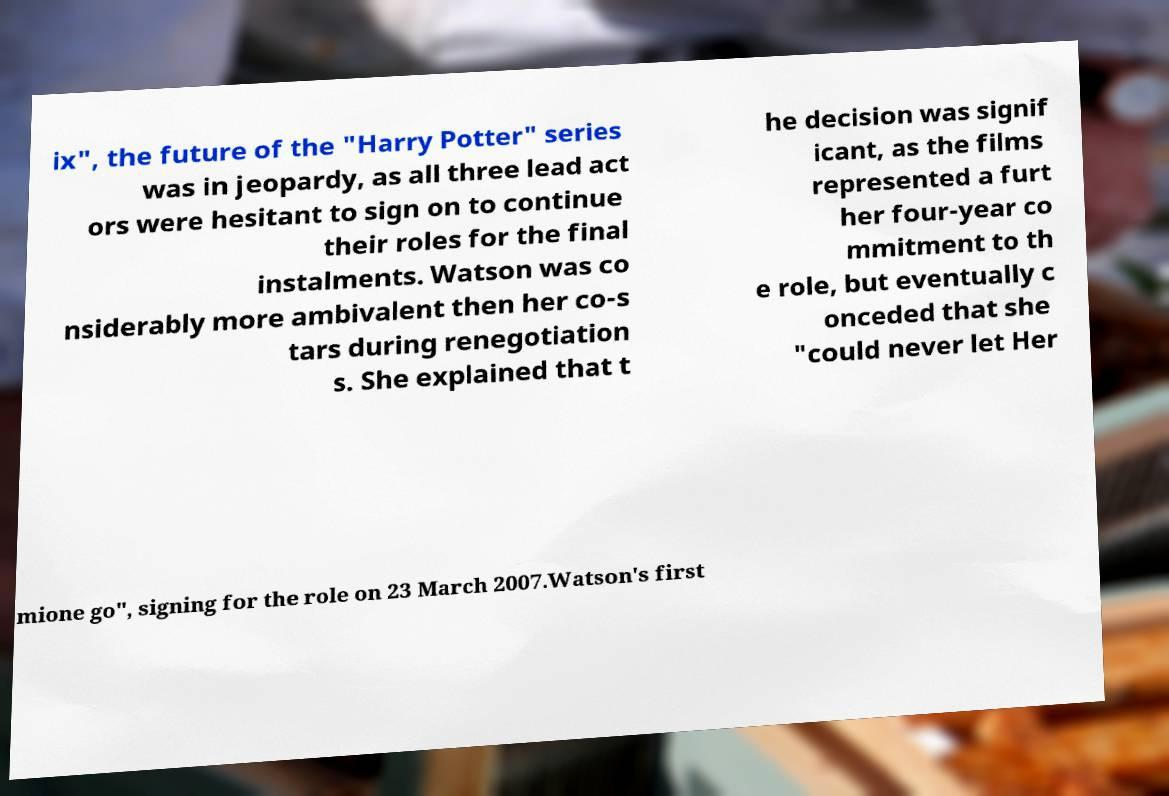Please read and relay the text visible in this image. What does it say? ix", the future of the "Harry Potter" series was in jeopardy, as all three lead act ors were hesitant to sign on to continue their roles for the final instalments. Watson was co nsiderably more ambivalent then her co-s tars during renegotiation s. She explained that t he decision was signif icant, as the films represented a furt her four-year co mmitment to th e role, but eventually c onceded that she "could never let Her mione go", signing for the role on 23 March 2007.Watson's first 